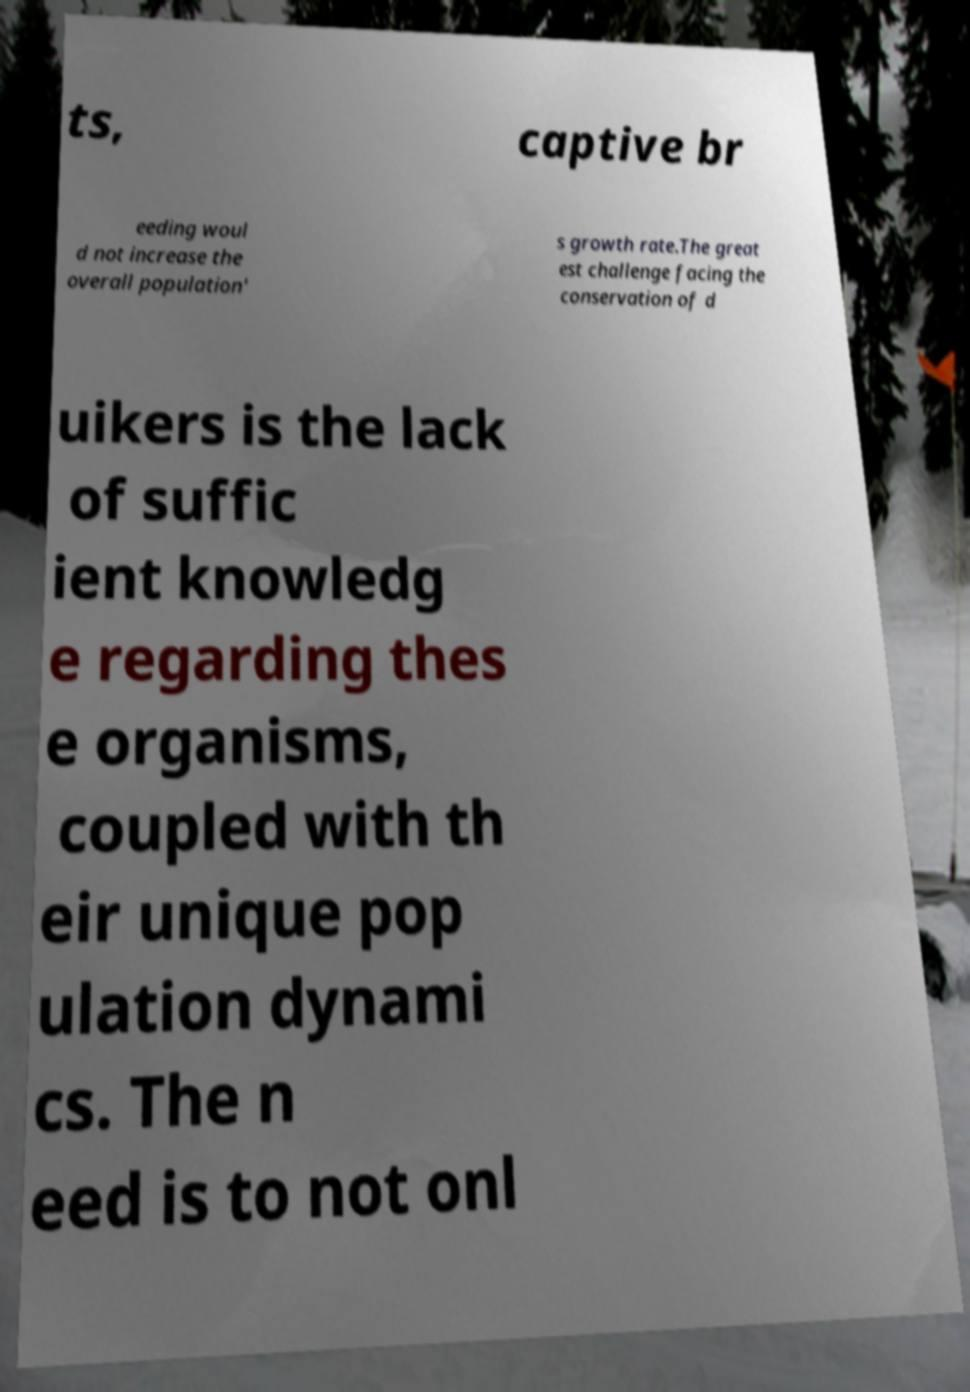There's text embedded in this image that I need extracted. Can you transcribe it verbatim? ts, captive br eeding woul d not increase the overall population' s growth rate.The great est challenge facing the conservation of d uikers is the lack of suffic ient knowledg e regarding thes e organisms, coupled with th eir unique pop ulation dynami cs. The n eed is to not onl 